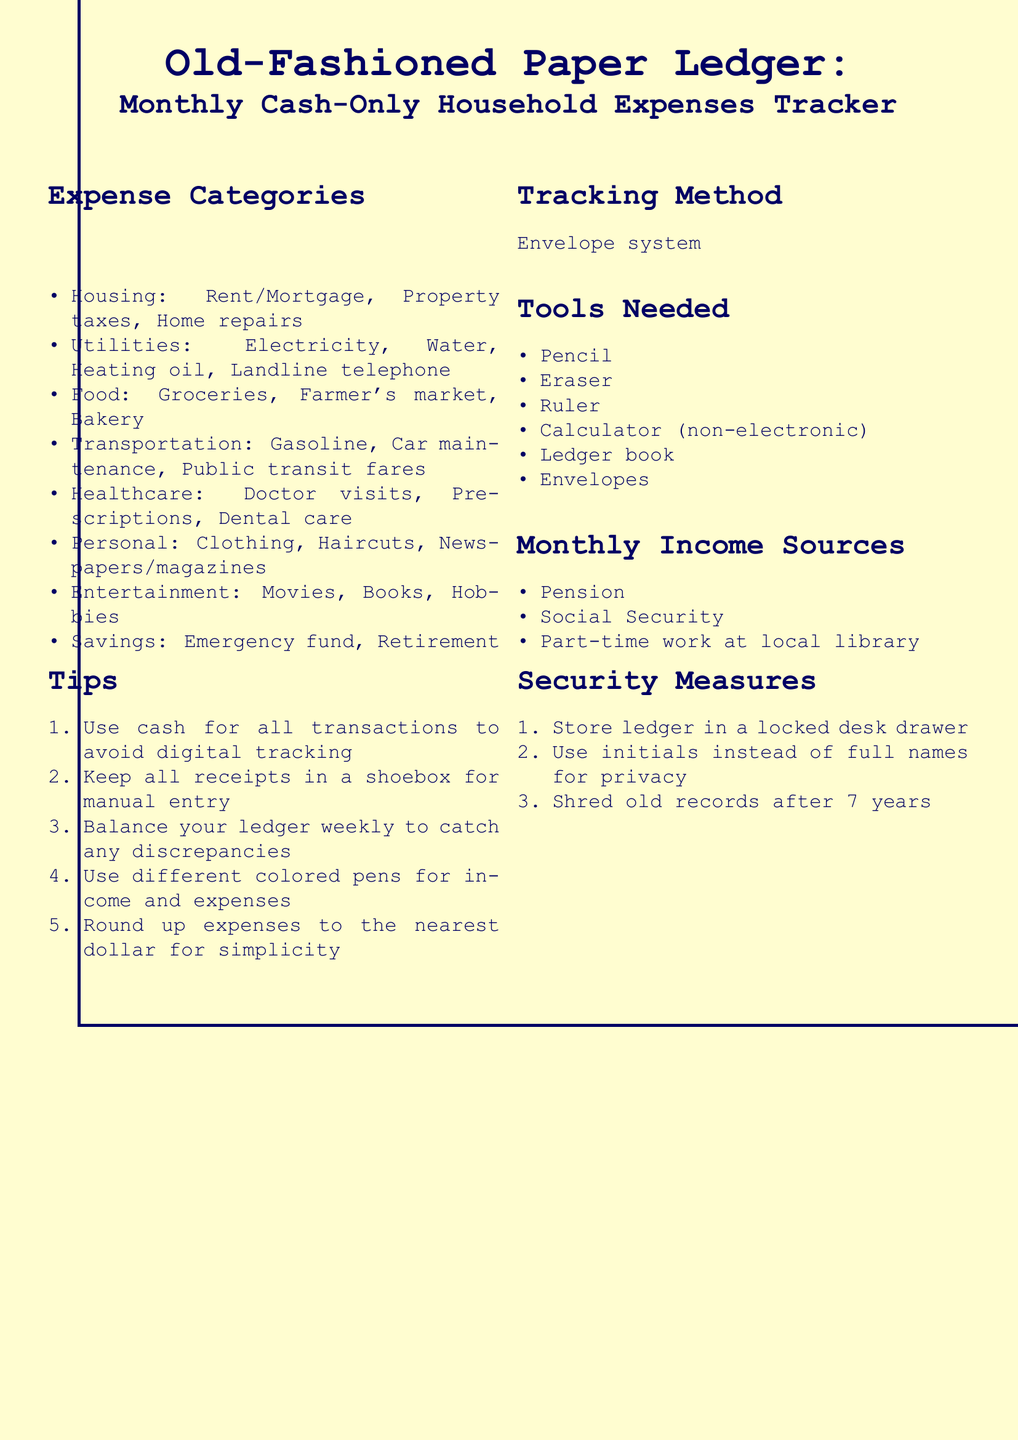What are the main expense categories? The main expense categories listed are Housing, Utilities, Food, Transportation, Healthcare, Personal, Entertainment, and Savings.
Answer: Housing, Utilities, Food, Transportation, Healthcare, Personal, Entertainment, Savings What is the suggested tracking method? The document suggests using the envelope system as the tracking method for expenses.
Answer: Envelope system What tools are needed for tracking expenses? The document lists tools including a pencil, eraser, ruler, non-electronic calculator, ledger book, and envelopes needed for tracking.
Answer: Pencil, eraser, ruler, non-electronic calculator, ledger book, envelopes What types of income sources are mentioned? The income sources mentioned include Pension, Social Security, and part-time work at a local library.
Answer: Pension, Social Security, part-time work at local library How many tips are provided for tracking expenses? There are five tips listed for tracking expenses effectively in the document.
Answer: Five What color should be used for distinguishing between income and expenses? The document recommends using different colored pens to denote income and expenses.
Answer: Different colored pens How long should old records be kept before shredding? The document states that old records should be shredded after seven years.
Answer: Seven years What is the suggested method for recording receipts? The document advises keeping all receipts in a shoebox for manual entry.
Answer: Shoebox 